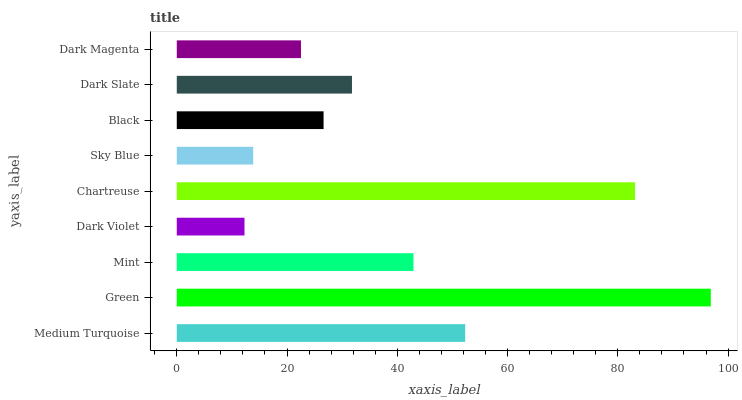Is Dark Violet the minimum?
Answer yes or no. Yes. Is Green the maximum?
Answer yes or no. Yes. Is Mint the minimum?
Answer yes or no. No. Is Mint the maximum?
Answer yes or no. No. Is Green greater than Mint?
Answer yes or no. Yes. Is Mint less than Green?
Answer yes or no. Yes. Is Mint greater than Green?
Answer yes or no. No. Is Green less than Mint?
Answer yes or no. No. Is Dark Slate the high median?
Answer yes or no. Yes. Is Dark Slate the low median?
Answer yes or no. Yes. Is Sky Blue the high median?
Answer yes or no. No. Is Sky Blue the low median?
Answer yes or no. No. 